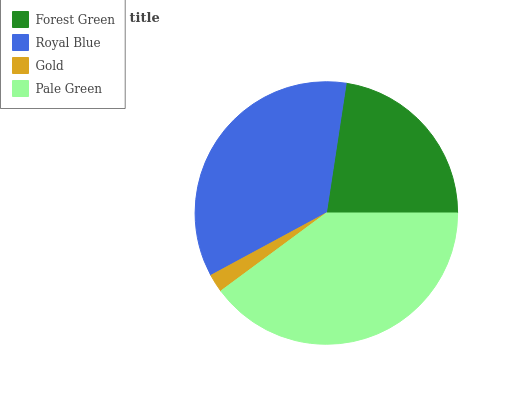Is Gold the minimum?
Answer yes or no. Yes. Is Pale Green the maximum?
Answer yes or no. Yes. Is Royal Blue the minimum?
Answer yes or no. No. Is Royal Blue the maximum?
Answer yes or no. No. Is Royal Blue greater than Forest Green?
Answer yes or no. Yes. Is Forest Green less than Royal Blue?
Answer yes or no. Yes. Is Forest Green greater than Royal Blue?
Answer yes or no. No. Is Royal Blue less than Forest Green?
Answer yes or no. No. Is Royal Blue the high median?
Answer yes or no. Yes. Is Forest Green the low median?
Answer yes or no. Yes. Is Forest Green the high median?
Answer yes or no. No. Is Pale Green the low median?
Answer yes or no. No. 